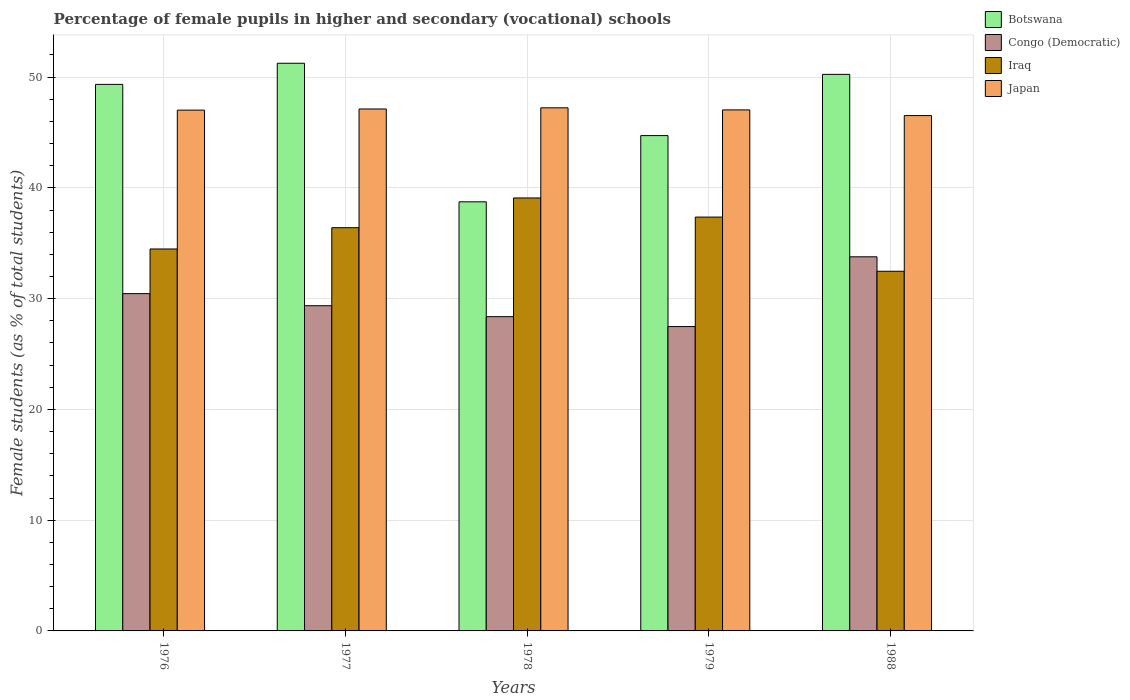How many different coloured bars are there?
Your answer should be compact. 4. How many groups of bars are there?
Provide a short and direct response. 5. Are the number of bars per tick equal to the number of legend labels?
Your response must be concise. Yes. Are the number of bars on each tick of the X-axis equal?
Make the answer very short. Yes. How many bars are there on the 2nd tick from the left?
Provide a succinct answer. 4. How many bars are there on the 1st tick from the right?
Make the answer very short. 4. What is the label of the 3rd group of bars from the left?
Provide a succinct answer. 1978. What is the percentage of female pupils in higher and secondary schools in Botswana in 1979?
Provide a short and direct response. 44.72. Across all years, what is the maximum percentage of female pupils in higher and secondary schools in Botswana?
Offer a terse response. 51.25. Across all years, what is the minimum percentage of female pupils in higher and secondary schools in Iraq?
Provide a succinct answer. 32.47. In which year was the percentage of female pupils in higher and secondary schools in Congo (Democratic) maximum?
Your response must be concise. 1988. In which year was the percentage of female pupils in higher and secondary schools in Botswana minimum?
Ensure brevity in your answer.  1978. What is the total percentage of female pupils in higher and secondary schools in Congo (Democratic) in the graph?
Offer a very short reply. 149.44. What is the difference between the percentage of female pupils in higher and secondary schools in Congo (Democratic) in 1977 and that in 1978?
Provide a succinct answer. 0.99. What is the difference between the percentage of female pupils in higher and secondary schools in Congo (Democratic) in 1988 and the percentage of female pupils in higher and secondary schools in Iraq in 1979?
Give a very brief answer. -3.59. What is the average percentage of female pupils in higher and secondary schools in Japan per year?
Make the answer very short. 46.99. In the year 1979, what is the difference between the percentage of female pupils in higher and secondary schools in Iraq and percentage of female pupils in higher and secondary schools in Congo (Democratic)?
Provide a succinct answer. 9.88. What is the ratio of the percentage of female pupils in higher and secondary schools in Congo (Democratic) in 1976 to that in 1979?
Offer a very short reply. 1.11. Is the percentage of female pupils in higher and secondary schools in Botswana in 1976 less than that in 1978?
Make the answer very short. No. Is the difference between the percentage of female pupils in higher and secondary schools in Iraq in 1979 and 1988 greater than the difference between the percentage of female pupils in higher and secondary schools in Congo (Democratic) in 1979 and 1988?
Your response must be concise. Yes. What is the difference between the highest and the second highest percentage of female pupils in higher and secondary schools in Congo (Democratic)?
Your response must be concise. 3.33. What is the difference between the highest and the lowest percentage of female pupils in higher and secondary schools in Congo (Democratic)?
Give a very brief answer. 6.3. Is the sum of the percentage of female pupils in higher and secondary schools in Congo (Democratic) in 1976 and 1988 greater than the maximum percentage of female pupils in higher and secondary schools in Japan across all years?
Keep it short and to the point. Yes. What does the 1st bar from the left in 1979 represents?
Offer a very short reply. Botswana. What does the 4th bar from the right in 1977 represents?
Your response must be concise. Botswana. Are all the bars in the graph horizontal?
Keep it short and to the point. No. How many years are there in the graph?
Your answer should be very brief. 5. What is the difference between two consecutive major ticks on the Y-axis?
Your answer should be compact. 10. Where does the legend appear in the graph?
Your response must be concise. Top right. How are the legend labels stacked?
Make the answer very short. Vertical. What is the title of the graph?
Provide a succinct answer. Percentage of female pupils in higher and secondary (vocational) schools. Does "American Samoa" appear as one of the legend labels in the graph?
Give a very brief answer. No. What is the label or title of the Y-axis?
Your answer should be compact. Female students (as % of total students). What is the Female students (as % of total students) of Botswana in 1976?
Your response must be concise. 49.34. What is the Female students (as % of total students) of Congo (Democratic) in 1976?
Give a very brief answer. 30.45. What is the Female students (as % of total students) of Iraq in 1976?
Give a very brief answer. 34.48. What is the Female students (as % of total students) in Japan in 1976?
Give a very brief answer. 47.02. What is the Female students (as % of total students) of Botswana in 1977?
Offer a very short reply. 51.25. What is the Female students (as % of total students) in Congo (Democratic) in 1977?
Offer a terse response. 29.36. What is the Female students (as % of total students) in Iraq in 1977?
Provide a succinct answer. 36.4. What is the Female students (as % of total students) of Japan in 1977?
Ensure brevity in your answer.  47.12. What is the Female students (as % of total students) in Botswana in 1978?
Your answer should be very brief. 38.74. What is the Female students (as % of total students) of Congo (Democratic) in 1978?
Make the answer very short. 28.37. What is the Female students (as % of total students) of Iraq in 1978?
Provide a short and direct response. 39.09. What is the Female students (as % of total students) in Japan in 1978?
Make the answer very short. 47.23. What is the Female students (as % of total students) in Botswana in 1979?
Provide a succinct answer. 44.72. What is the Female students (as % of total students) in Congo (Democratic) in 1979?
Provide a succinct answer. 27.48. What is the Female students (as % of total students) of Iraq in 1979?
Give a very brief answer. 37.36. What is the Female students (as % of total students) of Japan in 1979?
Provide a short and direct response. 47.04. What is the Female students (as % of total students) of Botswana in 1988?
Provide a succinct answer. 50.25. What is the Female students (as % of total students) in Congo (Democratic) in 1988?
Provide a succinct answer. 33.78. What is the Female students (as % of total students) in Iraq in 1988?
Offer a terse response. 32.47. What is the Female students (as % of total students) in Japan in 1988?
Offer a very short reply. 46.53. Across all years, what is the maximum Female students (as % of total students) of Botswana?
Give a very brief answer. 51.25. Across all years, what is the maximum Female students (as % of total students) of Congo (Democratic)?
Provide a short and direct response. 33.78. Across all years, what is the maximum Female students (as % of total students) in Iraq?
Your response must be concise. 39.09. Across all years, what is the maximum Female students (as % of total students) of Japan?
Keep it short and to the point. 47.23. Across all years, what is the minimum Female students (as % of total students) in Botswana?
Provide a short and direct response. 38.74. Across all years, what is the minimum Female students (as % of total students) of Congo (Democratic)?
Offer a very short reply. 27.48. Across all years, what is the minimum Female students (as % of total students) of Iraq?
Offer a terse response. 32.47. Across all years, what is the minimum Female students (as % of total students) of Japan?
Give a very brief answer. 46.53. What is the total Female students (as % of total students) of Botswana in the graph?
Your response must be concise. 234.3. What is the total Female students (as % of total students) of Congo (Democratic) in the graph?
Provide a short and direct response. 149.44. What is the total Female students (as % of total students) of Iraq in the graph?
Make the answer very short. 179.81. What is the total Female students (as % of total students) of Japan in the graph?
Offer a terse response. 234.93. What is the difference between the Female students (as % of total students) of Botswana in 1976 and that in 1977?
Make the answer very short. -1.91. What is the difference between the Female students (as % of total students) in Congo (Democratic) in 1976 and that in 1977?
Offer a very short reply. 1.09. What is the difference between the Female students (as % of total students) of Iraq in 1976 and that in 1977?
Your answer should be compact. -1.92. What is the difference between the Female students (as % of total students) of Japan in 1976 and that in 1977?
Your response must be concise. -0.11. What is the difference between the Female students (as % of total students) in Botswana in 1976 and that in 1978?
Offer a terse response. 10.6. What is the difference between the Female students (as % of total students) in Congo (Democratic) in 1976 and that in 1978?
Give a very brief answer. 2.08. What is the difference between the Female students (as % of total students) of Iraq in 1976 and that in 1978?
Make the answer very short. -4.61. What is the difference between the Female students (as % of total students) of Japan in 1976 and that in 1978?
Keep it short and to the point. -0.21. What is the difference between the Female students (as % of total students) of Botswana in 1976 and that in 1979?
Your answer should be very brief. 4.63. What is the difference between the Female students (as % of total students) in Congo (Democratic) in 1976 and that in 1979?
Your answer should be very brief. 2.97. What is the difference between the Female students (as % of total students) in Iraq in 1976 and that in 1979?
Your response must be concise. -2.88. What is the difference between the Female students (as % of total students) of Japan in 1976 and that in 1979?
Your answer should be very brief. -0.02. What is the difference between the Female students (as % of total students) in Botswana in 1976 and that in 1988?
Your response must be concise. -0.9. What is the difference between the Female students (as % of total students) of Congo (Democratic) in 1976 and that in 1988?
Your response must be concise. -3.33. What is the difference between the Female students (as % of total students) in Iraq in 1976 and that in 1988?
Provide a succinct answer. 2.01. What is the difference between the Female students (as % of total students) in Japan in 1976 and that in 1988?
Offer a very short reply. 0.49. What is the difference between the Female students (as % of total students) of Botswana in 1977 and that in 1978?
Keep it short and to the point. 12.51. What is the difference between the Female students (as % of total students) of Iraq in 1977 and that in 1978?
Offer a terse response. -2.68. What is the difference between the Female students (as % of total students) of Japan in 1977 and that in 1978?
Give a very brief answer. -0.1. What is the difference between the Female students (as % of total students) in Botswana in 1977 and that in 1979?
Provide a succinct answer. 6.53. What is the difference between the Female students (as % of total students) in Congo (Democratic) in 1977 and that in 1979?
Offer a very short reply. 1.88. What is the difference between the Female students (as % of total students) in Iraq in 1977 and that in 1979?
Provide a succinct answer. -0.96. What is the difference between the Female students (as % of total students) of Japan in 1977 and that in 1979?
Offer a very short reply. 0.08. What is the difference between the Female students (as % of total students) of Congo (Democratic) in 1977 and that in 1988?
Give a very brief answer. -4.42. What is the difference between the Female students (as % of total students) in Iraq in 1977 and that in 1988?
Your response must be concise. 3.93. What is the difference between the Female students (as % of total students) of Japan in 1977 and that in 1988?
Offer a terse response. 0.6. What is the difference between the Female students (as % of total students) of Botswana in 1978 and that in 1979?
Make the answer very short. -5.98. What is the difference between the Female students (as % of total students) in Congo (Democratic) in 1978 and that in 1979?
Provide a short and direct response. 0.89. What is the difference between the Female students (as % of total students) in Iraq in 1978 and that in 1979?
Give a very brief answer. 1.73. What is the difference between the Female students (as % of total students) of Japan in 1978 and that in 1979?
Give a very brief answer. 0.19. What is the difference between the Female students (as % of total students) in Botswana in 1978 and that in 1988?
Provide a succinct answer. -11.51. What is the difference between the Female students (as % of total students) of Congo (Democratic) in 1978 and that in 1988?
Offer a very short reply. -5.4. What is the difference between the Female students (as % of total students) of Iraq in 1978 and that in 1988?
Offer a very short reply. 6.62. What is the difference between the Female students (as % of total students) of Japan in 1978 and that in 1988?
Provide a short and direct response. 0.7. What is the difference between the Female students (as % of total students) in Botswana in 1979 and that in 1988?
Your answer should be very brief. -5.53. What is the difference between the Female students (as % of total students) of Congo (Democratic) in 1979 and that in 1988?
Offer a terse response. -6.3. What is the difference between the Female students (as % of total students) in Iraq in 1979 and that in 1988?
Ensure brevity in your answer.  4.89. What is the difference between the Female students (as % of total students) in Japan in 1979 and that in 1988?
Your answer should be very brief. 0.51. What is the difference between the Female students (as % of total students) of Botswana in 1976 and the Female students (as % of total students) of Congo (Democratic) in 1977?
Give a very brief answer. 19.98. What is the difference between the Female students (as % of total students) in Botswana in 1976 and the Female students (as % of total students) in Iraq in 1977?
Offer a terse response. 12.94. What is the difference between the Female students (as % of total students) of Botswana in 1976 and the Female students (as % of total students) of Japan in 1977?
Make the answer very short. 2.22. What is the difference between the Female students (as % of total students) in Congo (Democratic) in 1976 and the Female students (as % of total students) in Iraq in 1977?
Keep it short and to the point. -5.95. What is the difference between the Female students (as % of total students) in Congo (Democratic) in 1976 and the Female students (as % of total students) in Japan in 1977?
Offer a terse response. -16.67. What is the difference between the Female students (as % of total students) in Iraq in 1976 and the Female students (as % of total students) in Japan in 1977?
Offer a very short reply. -12.64. What is the difference between the Female students (as % of total students) in Botswana in 1976 and the Female students (as % of total students) in Congo (Democratic) in 1978?
Your response must be concise. 20.97. What is the difference between the Female students (as % of total students) of Botswana in 1976 and the Female students (as % of total students) of Iraq in 1978?
Keep it short and to the point. 10.26. What is the difference between the Female students (as % of total students) of Botswana in 1976 and the Female students (as % of total students) of Japan in 1978?
Offer a very short reply. 2.12. What is the difference between the Female students (as % of total students) of Congo (Democratic) in 1976 and the Female students (as % of total students) of Iraq in 1978?
Offer a terse response. -8.64. What is the difference between the Female students (as % of total students) of Congo (Democratic) in 1976 and the Female students (as % of total students) of Japan in 1978?
Provide a short and direct response. -16.78. What is the difference between the Female students (as % of total students) in Iraq in 1976 and the Female students (as % of total students) in Japan in 1978?
Provide a succinct answer. -12.74. What is the difference between the Female students (as % of total students) in Botswana in 1976 and the Female students (as % of total students) in Congo (Democratic) in 1979?
Offer a terse response. 21.87. What is the difference between the Female students (as % of total students) of Botswana in 1976 and the Female students (as % of total students) of Iraq in 1979?
Provide a succinct answer. 11.98. What is the difference between the Female students (as % of total students) of Botswana in 1976 and the Female students (as % of total students) of Japan in 1979?
Keep it short and to the point. 2.3. What is the difference between the Female students (as % of total students) of Congo (Democratic) in 1976 and the Female students (as % of total students) of Iraq in 1979?
Give a very brief answer. -6.91. What is the difference between the Female students (as % of total students) of Congo (Democratic) in 1976 and the Female students (as % of total students) of Japan in 1979?
Your answer should be very brief. -16.59. What is the difference between the Female students (as % of total students) of Iraq in 1976 and the Female students (as % of total students) of Japan in 1979?
Your response must be concise. -12.56. What is the difference between the Female students (as % of total students) of Botswana in 1976 and the Female students (as % of total students) of Congo (Democratic) in 1988?
Provide a short and direct response. 15.57. What is the difference between the Female students (as % of total students) in Botswana in 1976 and the Female students (as % of total students) in Iraq in 1988?
Your response must be concise. 16.87. What is the difference between the Female students (as % of total students) of Botswana in 1976 and the Female students (as % of total students) of Japan in 1988?
Keep it short and to the point. 2.82. What is the difference between the Female students (as % of total students) of Congo (Democratic) in 1976 and the Female students (as % of total students) of Iraq in 1988?
Your response must be concise. -2.02. What is the difference between the Female students (as % of total students) of Congo (Democratic) in 1976 and the Female students (as % of total students) of Japan in 1988?
Your answer should be compact. -16.07. What is the difference between the Female students (as % of total students) of Iraq in 1976 and the Female students (as % of total students) of Japan in 1988?
Keep it short and to the point. -12.04. What is the difference between the Female students (as % of total students) in Botswana in 1977 and the Female students (as % of total students) in Congo (Democratic) in 1978?
Offer a terse response. 22.88. What is the difference between the Female students (as % of total students) of Botswana in 1977 and the Female students (as % of total students) of Iraq in 1978?
Provide a succinct answer. 12.16. What is the difference between the Female students (as % of total students) of Botswana in 1977 and the Female students (as % of total students) of Japan in 1978?
Keep it short and to the point. 4.02. What is the difference between the Female students (as % of total students) in Congo (Democratic) in 1977 and the Female students (as % of total students) in Iraq in 1978?
Make the answer very short. -9.73. What is the difference between the Female students (as % of total students) in Congo (Democratic) in 1977 and the Female students (as % of total students) in Japan in 1978?
Offer a very short reply. -17.87. What is the difference between the Female students (as % of total students) of Iraq in 1977 and the Female students (as % of total students) of Japan in 1978?
Your answer should be compact. -10.82. What is the difference between the Female students (as % of total students) of Botswana in 1977 and the Female students (as % of total students) of Congo (Democratic) in 1979?
Ensure brevity in your answer.  23.77. What is the difference between the Female students (as % of total students) of Botswana in 1977 and the Female students (as % of total students) of Iraq in 1979?
Your response must be concise. 13.89. What is the difference between the Female students (as % of total students) of Botswana in 1977 and the Female students (as % of total students) of Japan in 1979?
Your answer should be compact. 4.21. What is the difference between the Female students (as % of total students) of Congo (Democratic) in 1977 and the Female students (as % of total students) of Iraq in 1979?
Offer a very short reply. -8. What is the difference between the Female students (as % of total students) in Congo (Democratic) in 1977 and the Female students (as % of total students) in Japan in 1979?
Provide a short and direct response. -17.68. What is the difference between the Female students (as % of total students) of Iraq in 1977 and the Female students (as % of total students) of Japan in 1979?
Ensure brevity in your answer.  -10.64. What is the difference between the Female students (as % of total students) of Botswana in 1977 and the Female students (as % of total students) of Congo (Democratic) in 1988?
Your answer should be compact. 17.47. What is the difference between the Female students (as % of total students) in Botswana in 1977 and the Female students (as % of total students) in Iraq in 1988?
Your response must be concise. 18.78. What is the difference between the Female students (as % of total students) of Botswana in 1977 and the Female students (as % of total students) of Japan in 1988?
Make the answer very short. 4.72. What is the difference between the Female students (as % of total students) of Congo (Democratic) in 1977 and the Female students (as % of total students) of Iraq in 1988?
Offer a terse response. -3.11. What is the difference between the Female students (as % of total students) in Congo (Democratic) in 1977 and the Female students (as % of total students) in Japan in 1988?
Ensure brevity in your answer.  -17.16. What is the difference between the Female students (as % of total students) in Iraq in 1977 and the Female students (as % of total students) in Japan in 1988?
Ensure brevity in your answer.  -10.12. What is the difference between the Female students (as % of total students) of Botswana in 1978 and the Female students (as % of total students) of Congo (Democratic) in 1979?
Make the answer very short. 11.26. What is the difference between the Female students (as % of total students) of Botswana in 1978 and the Female students (as % of total students) of Iraq in 1979?
Keep it short and to the point. 1.38. What is the difference between the Female students (as % of total students) of Botswana in 1978 and the Female students (as % of total students) of Japan in 1979?
Ensure brevity in your answer.  -8.3. What is the difference between the Female students (as % of total students) of Congo (Democratic) in 1978 and the Female students (as % of total students) of Iraq in 1979?
Offer a very short reply. -8.99. What is the difference between the Female students (as % of total students) in Congo (Democratic) in 1978 and the Female students (as % of total students) in Japan in 1979?
Ensure brevity in your answer.  -18.67. What is the difference between the Female students (as % of total students) in Iraq in 1978 and the Female students (as % of total students) in Japan in 1979?
Keep it short and to the point. -7.95. What is the difference between the Female students (as % of total students) of Botswana in 1978 and the Female students (as % of total students) of Congo (Democratic) in 1988?
Offer a terse response. 4.96. What is the difference between the Female students (as % of total students) of Botswana in 1978 and the Female students (as % of total students) of Iraq in 1988?
Keep it short and to the point. 6.27. What is the difference between the Female students (as % of total students) of Botswana in 1978 and the Female students (as % of total students) of Japan in 1988?
Provide a short and direct response. -7.78. What is the difference between the Female students (as % of total students) of Congo (Democratic) in 1978 and the Female students (as % of total students) of Iraq in 1988?
Provide a short and direct response. -4.1. What is the difference between the Female students (as % of total students) in Congo (Democratic) in 1978 and the Female students (as % of total students) in Japan in 1988?
Your answer should be very brief. -18.15. What is the difference between the Female students (as % of total students) in Iraq in 1978 and the Female students (as % of total students) in Japan in 1988?
Your answer should be compact. -7.44. What is the difference between the Female students (as % of total students) of Botswana in 1979 and the Female students (as % of total students) of Congo (Democratic) in 1988?
Offer a terse response. 10.94. What is the difference between the Female students (as % of total students) of Botswana in 1979 and the Female students (as % of total students) of Iraq in 1988?
Provide a short and direct response. 12.25. What is the difference between the Female students (as % of total students) in Botswana in 1979 and the Female students (as % of total students) in Japan in 1988?
Provide a succinct answer. -1.81. What is the difference between the Female students (as % of total students) in Congo (Democratic) in 1979 and the Female students (as % of total students) in Iraq in 1988?
Provide a succinct answer. -4.99. What is the difference between the Female students (as % of total students) in Congo (Democratic) in 1979 and the Female students (as % of total students) in Japan in 1988?
Keep it short and to the point. -19.05. What is the difference between the Female students (as % of total students) of Iraq in 1979 and the Female students (as % of total students) of Japan in 1988?
Offer a very short reply. -9.16. What is the average Female students (as % of total students) of Botswana per year?
Offer a terse response. 46.86. What is the average Female students (as % of total students) of Congo (Democratic) per year?
Offer a terse response. 29.89. What is the average Female students (as % of total students) of Iraq per year?
Provide a succinct answer. 35.96. What is the average Female students (as % of total students) in Japan per year?
Make the answer very short. 46.99. In the year 1976, what is the difference between the Female students (as % of total students) in Botswana and Female students (as % of total students) in Congo (Democratic)?
Offer a very short reply. 18.89. In the year 1976, what is the difference between the Female students (as % of total students) in Botswana and Female students (as % of total students) in Iraq?
Offer a very short reply. 14.86. In the year 1976, what is the difference between the Female students (as % of total students) in Botswana and Female students (as % of total students) in Japan?
Make the answer very short. 2.33. In the year 1976, what is the difference between the Female students (as % of total students) in Congo (Democratic) and Female students (as % of total students) in Iraq?
Offer a very short reply. -4.03. In the year 1976, what is the difference between the Female students (as % of total students) of Congo (Democratic) and Female students (as % of total students) of Japan?
Give a very brief answer. -16.57. In the year 1976, what is the difference between the Female students (as % of total students) of Iraq and Female students (as % of total students) of Japan?
Provide a short and direct response. -12.53. In the year 1977, what is the difference between the Female students (as % of total students) of Botswana and Female students (as % of total students) of Congo (Democratic)?
Give a very brief answer. 21.89. In the year 1977, what is the difference between the Female students (as % of total students) of Botswana and Female students (as % of total students) of Iraq?
Make the answer very short. 14.85. In the year 1977, what is the difference between the Female students (as % of total students) in Botswana and Female students (as % of total students) in Japan?
Your answer should be compact. 4.13. In the year 1977, what is the difference between the Female students (as % of total students) of Congo (Democratic) and Female students (as % of total students) of Iraq?
Make the answer very short. -7.04. In the year 1977, what is the difference between the Female students (as % of total students) of Congo (Democratic) and Female students (as % of total students) of Japan?
Your response must be concise. -17.76. In the year 1977, what is the difference between the Female students (as % of total students) in Iraq and Female students (as % of total students) in Japan?
Your answer should be very brief. -10.72. In the year 1978, what is the difference between the Female students (as % of total students) in Botswana and Female students (as % of total students) in Congo (Democratic)?
Offer a very short reply. 10.37. In the year 1978, what is the difference between the Female students (as % of total students) in Botswana and Female students (as % of total students) in Iraq?
Provide a short and direct response. -0.35. In the year 1978, what is the difference between the Female students (as % of total students) in Botswana and Female students (as % of total students) in Japan?
Ensure brevity in your answer.  -8.49. In the year 1978, what is the difference between the Female students (as % of total students) in Congo (Democratic) and Female students (as % of total students) in Iraq?
Provide a short and direct response. -10.72. In the year 1978, what is the difference between the Female students (as % of total students) of Congo (Democratic) and Female students (as % of total students) of Japan?
Offer a very short reply. -18.85. In the year 1978, what is the difference between the Female students (as % of total students) in Iraq and Female students (as % of total students) in Japan?
Offer a terse response. -8.14. In the year 1979, what is the difference between the Female students (as % of total students) of Botswana and Female students (as % of total students) of Congo (Democratic)?
Offer a terse response. 17.24. In the year 1979, what is the difference between the Female students (as % of total students) of Botswana and Female students (as % of total students) of Iraq?
Make the answer very short. 7.36. In the year 1979, what is the difference between the Female students (as % of total students) of Botswana and Female students (as % of total students) of Japan?
Your answer should be very brief. -2.32. In the year 1979, what is the difference between the Female students (as % of total students) of Congo (Democratic) and Female students (as % of total students) of Iraq?
Your response must be concise. -9.88. In the year 1979, what is the difference between the Female students (as % of total students) of Congo (Democratic) and Female students (as % of total students) of Japan?
Ensure brevity in your answer.  -19.56. In the year 1979, what is the difference between the Female students (as % of total students) of Iraq and Female students (as % of total students) of Japan?
Give a very brief answer. -9.68. In the year 1988, what is the difference between the Female students (as % of total students) in Botswana and Female students (as % of total students) in Congo (Democratic)?
Provide a succinct answer. 16.47. In the year 1988, what is the difference between the Female students (as % of total students) of Botswana and Female students (as % of total students) of Iraq?
Ensure brevity in your answer.  17.78. In the year 1988, what is the difference between the Female students (as % of total students) in Botswana and Female students (as % of total students) in Japan?
Make the answer very short. 3.72. In the year 1988, what is the difference between the Female students (as % of total students) of Congo (Democratic) and Female students (as % of total students) of Iraq?
Keep it short and to the point. 1.31. In the year 1988, what is the difference between the Female students (as % of total students) in Congo (Democratic) and Female students (as % of total students) in Japan?
Offer a very short reply. -12.75. In the year 1988, what is the difference between the Female students (as % of total students) in Iraq and Female students (as % of total students) in Japan?
Your answer should be compact. -14.05. What is the ratio of the Female students (as % of total students) in Botswana in 1976 to that in 1977?
Make the answer very short. 0.96. What is the ratio of the Female students (as % of total students) of Congo (Democratic) in 1976 to that in 1977?
Your response must be concise. 1.04. What is the ratio of the Female students (as % of total students) in Iraq in 1976 to that in 1977?
Offer a terse response. 0.95. What is the ratio of the Female students (as % of total students) in Japan in 1976 to that in 1977?
Your answer should be compact. 1. What is the ratio of the Female students (as % of total students) of Botswana in 1976 to that in 1978?
Make the answer very short. 1.27. What is the ratio of the Female students (as % of total students) in Congo (Democratic) in 1976 to that in 1978?
Your answer should be very brief. 1.07. What is the ratio of the Female students (as % of total students) in Iraq in 1976 to that in 1978?
Your response must be concise. 0.88. What is the ratio of the Female students (as % of total students) of Japan in 1976 to that in 1978?
Your answer should be compact. 1. What is the ratio of the Female students (as % of total students) of Botswana in 1976 to that in 1979?
Your answer should be very brief. 1.1. What is the ratio of the Female students (as % of total students) of Congo (Democratic) in 1976 to that in 1979?
Make the answer very short. 1.11. What is the ratio of the Female students (as % of total students) of Iraq in 1976 to that in 1979?
Offer a very short reply. 0.92. What is the ratio of the Female students (as % of total students) of Congo (Democratic) in 1976 to that in 1988?
Your answer should be compact. 0.9. What is the ratio of the Female students (as % of total students) in Iraq in 1976 to that in 1988?
Your answer should be compact. 1.06. What is the ratio of the Female students (as % of total students) of Japan in 1976 to that in 1988?
Offer a terse response. 1.01. What is the ratio of the Female students (as % of total students) of Botswana in 1977 to that in 1978?
Your response must be concise. 1.32. What is the ratio of the Female students (as % of total students) of Congo (Democratic) in 1977 to that in 1978?
Your answer should be very brief. 1.03. What is the ratio of the Female students (as % of total students) in Iraq in 1977 to that in 1978?
Your response must be concise. 0.93. What is the ratio of the Female students (as % of total students) of Japan in 1977 to that in 1978?
Provide a succinct answer. 1. What is the ratio of the Female students (as % of total students) of Botswana in 1977 to that in 1979?
Keep it short and to the point. 1.15. What is the ratio of the Female students (as % of total students) of Congo (Democratic) in 1977 to that in 1979?
Make the answer very short. 1.07. What is the ratio of the Female students (as % of total students) in Iraq in 1977 to that in 1979?
Offer a very short reply. 0.97. What is the ratio of the Female students (as % of total students) of Botswana in 1977 to that in 1988?
Keep it short and to the point. 1.02. What is the ratio of the Female students (as % of total students) in Congo (Democratic) in 1977 to that in 1988?
Keep it short and to the point. 0.87. What is the ratio of the Female students (as % of total students) of Iraq in 1977 to that in 1988?
Your response must be concise. 1.12. What is the ratio of the Female students (as % of total students) of Japan in 1977 to that in 1988?
Keep it short and to the point. 1.01. What is the ratio of the Female students (as % of total students) in Botswana in 1978 to that in 1979?
Keep it short and to the point. 0.87. What is the ratio of the Female students (as % of total students) in Congo (Democratic) in 1978 to that in 1979?
Offer a terse response. 1.03. What is the ratio of the Female students (as % of total students) in Iraq in 1978 to that in 1979?
Your answer should be very brief. 1.05. What is the ratio of the Female students (as % of total students) in Botswana in 1978 to that in 1988?
Your answer should be very brief. 0.77. What is the ratio of the Female students (as % of total students) of Congo (Democratic) in 1978 to that in 1988?
Provide a short and direct response. 0.84. What is the ratio of the Female students (as % of total students) in Iraq in 1978 to that in 1988?
Keep it short and to the point. 1.2. What is the ratio of the Female students (as % of total students) of Japan in 1978 to that in 1988?
Your answer should be compact. 1.02. What is the ratio of the Female students (as % of total students) of Botswana in 1979 to that in 1988?
Offer a terse response. 0.89. What is the ratio of the Female students (as % of total students) of Congo (Democratic) in 1979 to that in 1988?
Your answer should be compact. 0.81. What is the ratio of the Female students (as % of total students) in Iraq in 1979 to that in 1988?
Ensure brevity in your answer.  1.15. What is the ratio of the Female students (as % of total students) in Japan in 1979 to that in 1988?
Provide a succinct answer. 1.01. What is the difference between the highest and the second highest Female students (as % of total students) of Botswana?
Provide a short and direct response. 1. What is the difference between the highest and the second highest Female students (as % of total students) of Congo (Democratic)?
Your answer should be very brief. 3.33. What is the difference between the highest and the second highest Female students (as % of total students) of Iraq?
Offer a terse response. 1.73. What is the difference between the highest and the second highest Female students (as % of total students) of Japan?
Ensure brevity in your answer.  0.1. What is the difference between the highest and the lowest Female students (as % of total students) in Botswana?
Keep it short and to the point. 12.51. What is the difference between the highest and the lowest Female students (as % of total students) in Congo (Democratic)?
Your answer should be very brief. 6.3. What is the difference between the highest and the lowest Female students (as % of total students) in Iraq?
Provide a short and direct response. 6.62. What is the difference between the highest and the lowest Female students (as % of total students) of Japan?
Your answer should be compact. 0.7. 